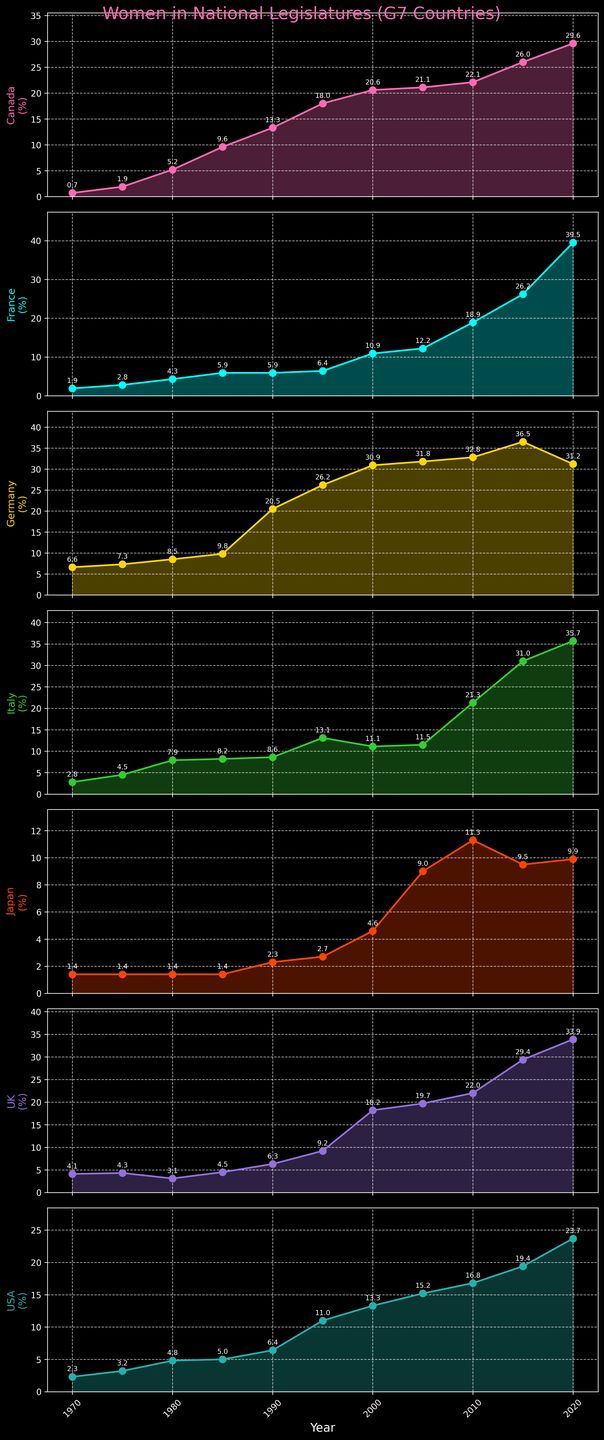What's the general trend of the percentage of women elected to national legislatures in G7 countries over the past 50 years? To determine the general trend, observe the direction of the lines in each subplot. All the lines generally slope upwards from 1970 to 2020. This signifies that the percentage of women elected to national legislatures in G7 countries has increased over the past 50 years.
Answer: Upward Which country had the highest percentage of women in its national legislature in 2020? Look at the data points in the year 2020 for each subplot. The highest data point is 39.5% in France.
Answer: France In what year did Germany first surpass a 20% representation of women in its national legislature? Examine Germany's subplot and identify the year where the percentage first exceeds 20%. This happens in 1990.
Answer: 1990 Compare the percentages of women elected in Canada and Japan in 1985. How many times higher is the percentage in Canada compared to Japan? Find the data points for 1985 in both Canada and Japan's subplots. Canada is at 9.6%, and Japan is at 1.4%. Calculate the ratio of these percentages: 9.6 / 1.4 ≈ 6.86 times higher.
Answer: ≈6.86 times Between 1995 and 2000, which G7 country experienced the largest increase in the percentage of women in its national legislature, and what was the increase? Calculate the difference in percentages from 1995 to 2000 for all countries and compare them. Germany shows an increase from 26.2% to 30.9%, which is the largest increase of 4.7%.
Answer: Germany, 4.7% How does the UK’s representation of women in national legislatures in 2020 compare to its representation in 1970? Compare the data points for the UK in 1970 (4.1%) and 2020 (33.9%). Subtract to find the difference: 33.9% - 4.1% = 29.8%.
Answer: It increased by 29.8% What was the average percentage of women in national legislatures across all G7 countries in 2015? Calculate the average by summing the 2015 percentages for all G7 countries and dividing by the number of countries. (26.0 + 26.2 + 36.5 + 31.0 + 9.5 + 29.4 + 19.4) / 7 ≈ 25.71%.
Answer: ≈25.71% Which country showed the most significant improvement between 1970 and 2020, and by how much? Find the difference in percentages between 1970 and 2020 for each country and identify the maximum improvement. France had the largest improvement from 1.9% to 39.5%, an increase of 37.6%.
Answer: France, 37.6% 